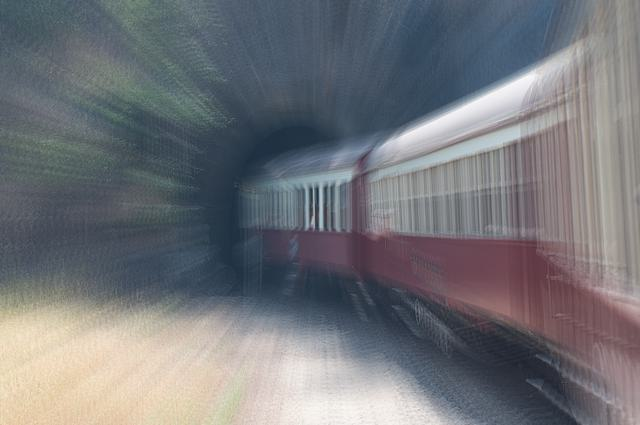Could this photo be used in advertising? If so, what kind of message could it represent? Absolutely, this photo could be effective in advertising contexts that aim to highlight themes of speed, efficiency, and modernity. For instance, a railway company might use it to tout the quick travel times of their trains, or a technology firm could use it metaphorically to suggest rapid innovation and forward momentum. In what other contexts could this style of photography be suitable? This style of photography, with its strong sense of movement, could be well-suited for editorial pieces about travel, the pace of urban life, or subjects relating to time. It could also be used in artistic exhibitions exploring the theme of motion or the human experience with modern transportation. 